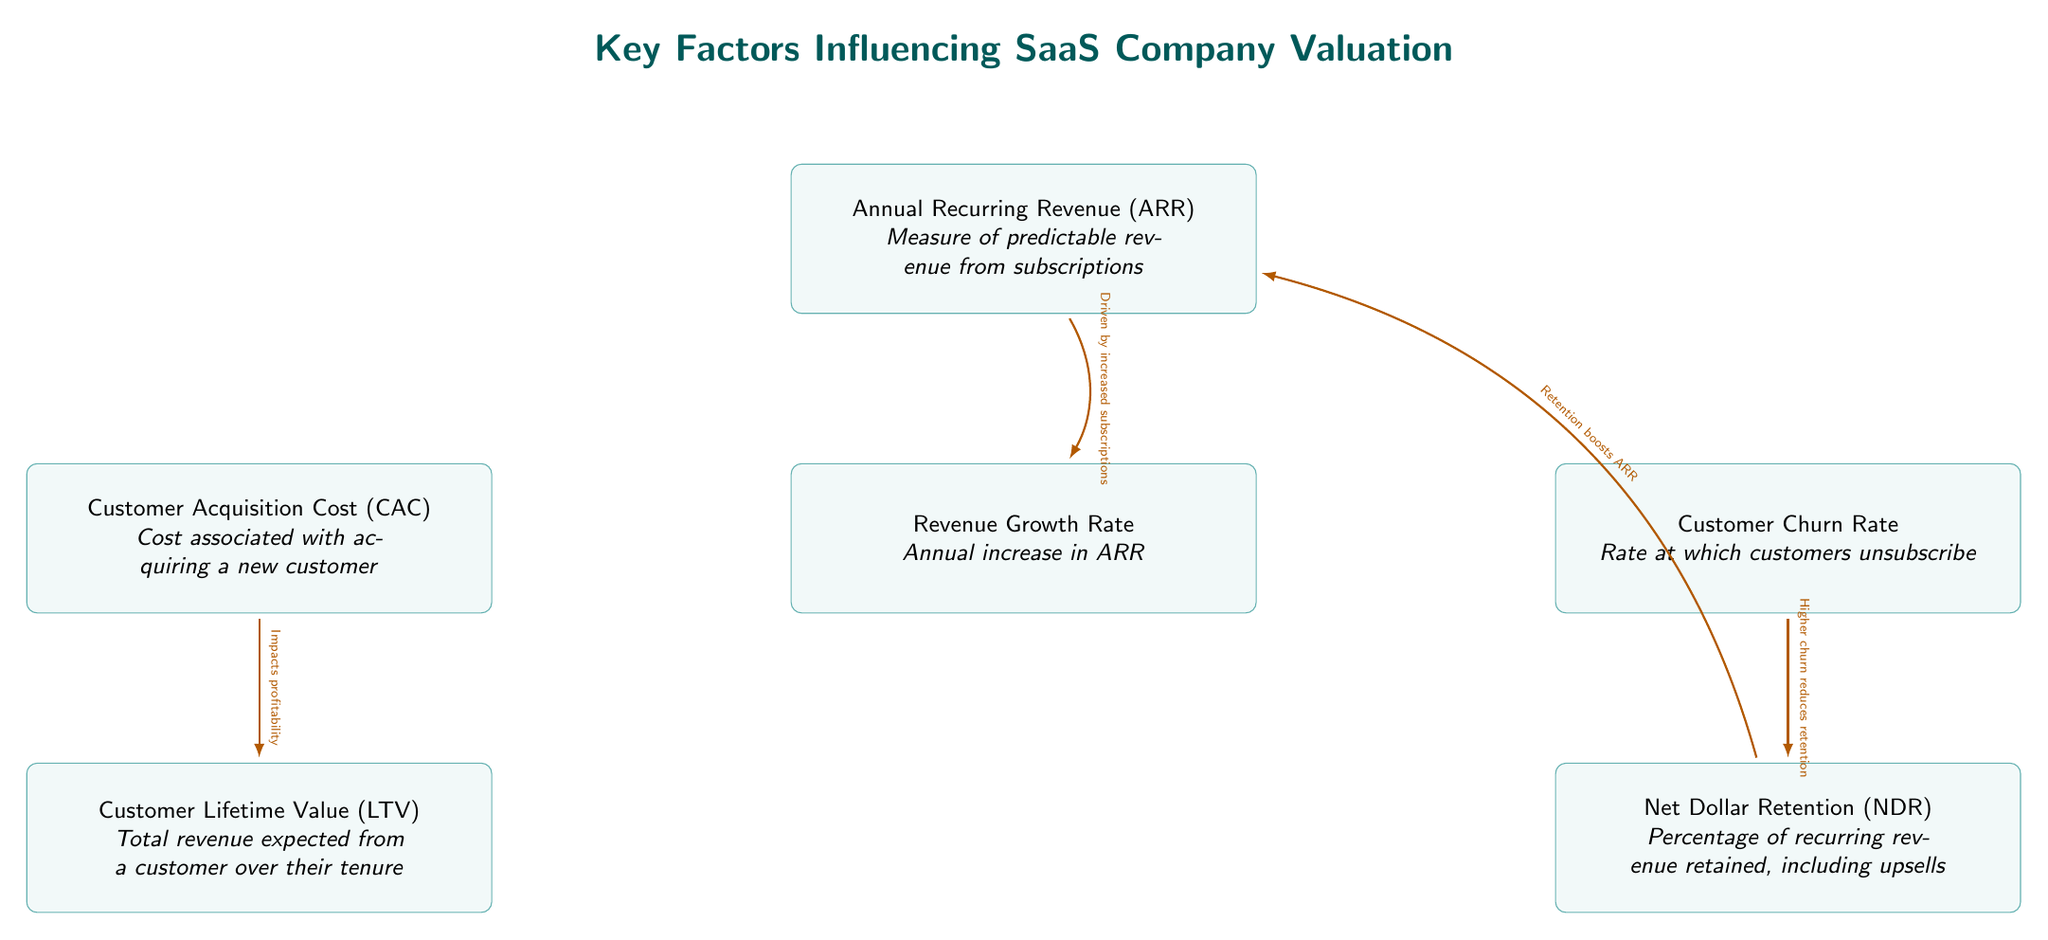What are the key metrics influencing SaaS company valuation? The diagram explicitly outlines five key metrics: Annual Recurring Revenue, Customer Acquisition Cost, Customer Churn Rate, Customer Lifetime Value, and Net Dollar Retention. Each is represented as a node.
Answer: Annual Recurring Revenue, Customer Acquisition Cost, Customer Churn Rate, Customer Lifetime Value, Net Dollar Retention How many nodes are present in the diagram? The diagram features a total of six nodes: one for Annual Recurring Revenue and one each for Customer Acquisition Cost, Customer Churn Rate, Customer Lifetime Value, Net Dollar Retention, and Revenue Growth Rate.
Answer: Six What is the relationship between Customer Churn Rate and Net Dollar Retention? The diagram shows an arrow from Customer Churn Rate to Net Dollar Retention, indicating that a higher churn reduces retention, which affects NDR negatively.
Answer: Higher churn reduces retention What drives Revenue Growth Rate according to the diagram? The arrow from Annual Recurring Revenue to Revenue Growth Rate suggests that growth is driven by increased subscriptions for the recurring revenue.
Answer: Increased subscriptions How does Net Dollar Retention influence Annual Recurring Revenue? Net Dollar Retention has a bending arrow pointing back to Annual Recurring Revenue with a note stating, "Retention boosts ARR," meaning that higher retention rates contribute to increasing ARR.
Answer: Retention boosts ARR What impact does Customer Acquisition Cost have on Customer Lifetime Value? The diagram shows a direct arrow from Customer Acquisition Cost to Customer Lifetime Value, indicating that CAC impacts profitability, which in turn affects LTV.
Answer: Impacts profitability What type of revenue measure is Annual Recurring Revenue described as? The diagram describes Annual Recurring Revenue as a measure of predictable revenue from subscriptions, characterizing it as a stable revenue metric.
Answer: Measure of predictable revenue from subscriptions Which metric directly relates to how much revenue is retained from existing customers? The metric Net Dollar Retention directly relates to the percentage of recurring revenue retained from existing customers, including any upsells.
Answer: Net Dollar Retention What is the significance of Customer Lifetime Value in relation to Customer Acquisition Cost? Customer Lifetime Value represents the total revenue expected from a customer over their tenure, and it is crucial as it shows the return on the investment made in Customer Acquisition Cost.
Answer: Total revenue expected from a customer over their tenure 